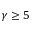<formula> <loc_0><loc_0><loc_500><loc_500>\gamma \geq 5</formula> 